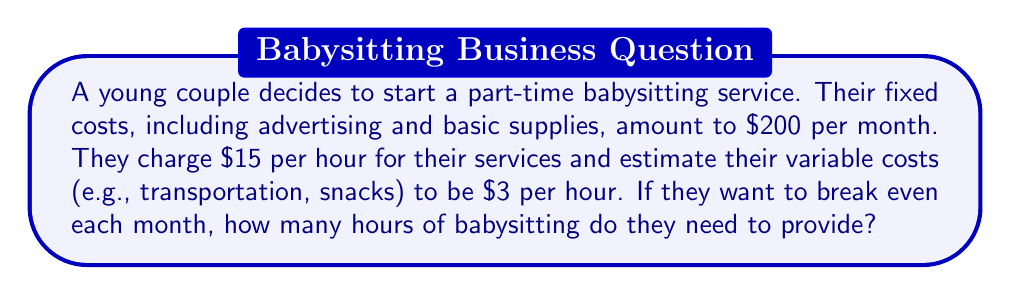Show me your answer to this math problem. To solve this problem, we need to use the break-even analysis formula. The break-even point is where total revenue equals total costs.

Let's define our variables:
$x$ = number of hours of babysitting
$P$ = price per hour = $15
$V$ = variable cost per hour = $3
$F$ = fixed costs per month = $200

The break-even formula is:

$$ Px = F + Vx $$

Where $Px$ represents total revenue, and $F + Vx$ represents total costs.

Substituting our values:

$$ 15x = 200 + 3x $$

Now, let's solve for $x$:

$$ 15x - 3x = 200 $$
$$ 12x = 200 $$
$$ x = \frac{200}{12} $$
$$ x = 16.67 $$

Since we can't babysit for a fractional hour, we round up to the nearest whole number.
Answer: The couple needs to provide 17 hours of babysitting per month to break even. 